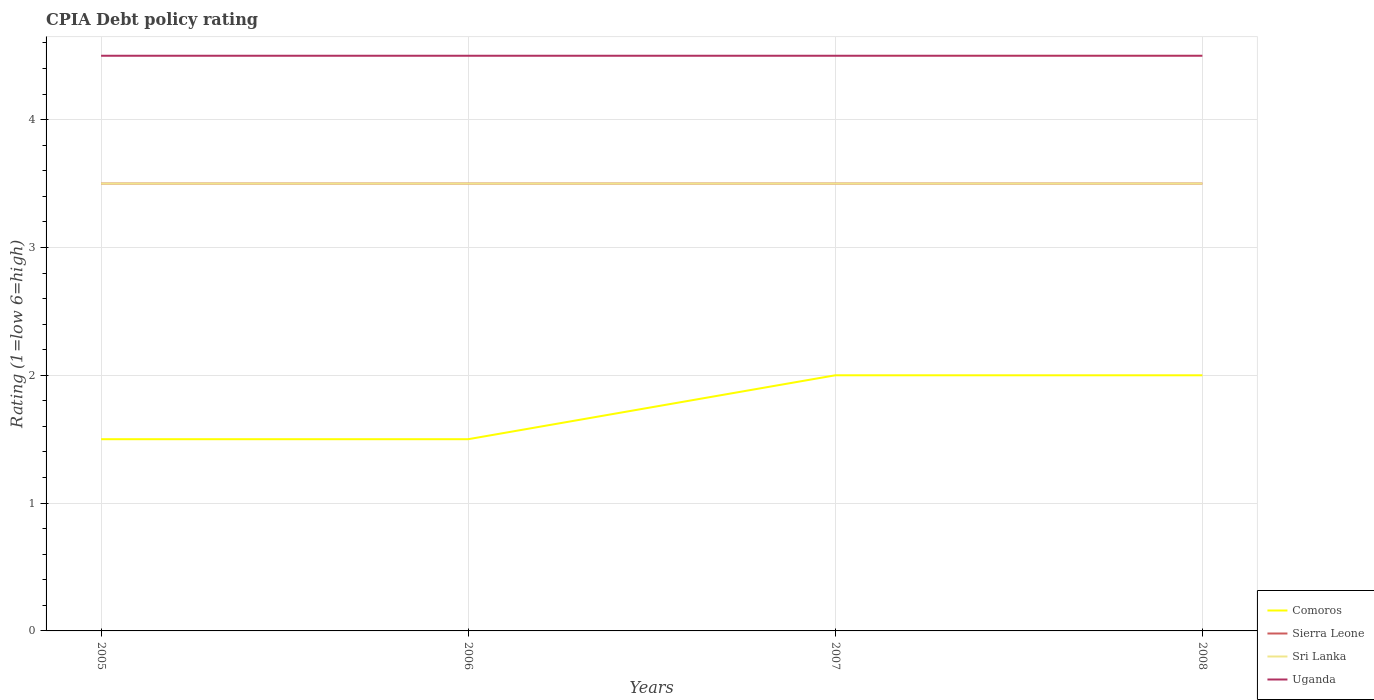Across all years, what is the maximum CPIA rating in Uganda?
Offer a terse response. 4.5. What is the difference between the highest and the second highest CPIA rating in Sri Lanka?
Ensure brevity in your answer.  0. Is the CPIA rating in Sri Lanka strictly greater than the CPIA rating in Sierra Leone over the years?
Your answer should be compact. No. How many years are there in the graph?
Your answer should be very brief. 4. What is the difference between two consecutive major ticks on the Y-axis?
Offer a terse response. 1. Are the values on the major ticks of Y-axis written in scientific E-notation?
Make the answer very short. No. Does the graph contain any zero values?
Give a very brief answer. No. Does the graph contain grids?
Offer a terse response. Yes. Where does the legend appear in the graph?
Make the answer very short. Bottom right. How many legend labels are there?
Your response must be concise. 4. How are the legend labels stacked?
Make the answer very short. Vertical. What is the title of the graph?
Provide a succinct answer. CPIA Debt policy rating. What is the label or title of the X-axis?
Offer a terse response. Years. What is the Rating (1=low 6=high) in Comoros in 2005?
Your answer should be very brief. 1.5. What is the Rating (1=low 6=high) of Comoros in 2006?
Offer a terse response. 1.5. What is the Rating (1=low 6=high) of Sierra Leone in 2006?
Your answer should be compact. 3.5. What is the Rating (1=low 6=high) in Comoros in 2007?
Give a very brief answer. 2. What is the Rating (1=low 6=high) in Sri Lanka in 2007?
Ensure brevity in your answer.  3.5. What is the Rating (1=low 6=high) of Uganda in 2007?
Make the answer very short. 4.5. What is the Rating (1=low 6=high) of Sierra Leone in 2008?
Make the answer very short. 3.5. What is the Rating (1=low 6=high) of Uganda in 2008?
Make the answer very short. 4.5. Across all years, what is the maximum Rating (1=low 6=high) of Sierra Leone?
Offer a terse response. 3.5. Across all years, what is the maximum Rating (1=low 6=high) of Uganda?
Your response must be concise. 4.5. Across all years, what is the minimum Rating (1=low 6=high) of Sierra Leone?
Offer a terse response. 3.5. Across all years, what is the minimum Rating (1=low 6=high) of Sri Lanka?
Provide a succinct answer. 3.5. Across all years, what is the minimum Rating (1=low 6=high) of Uganda?
Offer a very short reply. 4.5. What is the total Rating (1=low 6=high) of Comoros in the graph?
Offer a terse response. 7. What is the difference between the Rating (1=low 6=high) of Comoros in 2005 and that in 2006?
Provide a succinct answer. 0. What is the difference between the Rating (1=low 6=high) in Sierra Leone in 2005 and that in 2006?
Your response must be concise. 0. What is the difference between the Rating (1=low 6=high) of Uganda in 2005 and that in 2006?
Offer a terse response. 0. What is the difference between the Rating (1=low 6=high) in Sri Lanka in 2005 and that in 2007?
Provide a succinct answer. 0. What is the difference between the Rating (1=low 6=high) of Uganda in 2005 and that in 2007?
Ensure brevity in your answer.  0. What is the difference between the Rating (1=low 6=high) in Sri Lanka in 2005 and that in 2008?
Give a very brief answer. 0. What is the difference between the Rating (1=low 6=high) in Uganda in 2005 and that in 2008?
Provide a succinct answer. 0. What is the difference between the Rating (1=low 6=high) in Uganda in 2006 and that in 2007?
Offer a terse response. 0. What is the difference between the Rating (1=low 6=high) of Comoros in 2006 and that in 2008?
Give a very brief answer. -0.5. What is the difference between the Rating (1=low 6=high) in Sierra Leone in 2006 and that in 2008?
Give a very brief answer. 0. What is the difference between the Rating (1=low 6=high) of Sri Lanka in 2006 and that in 2008?
Ensure brevity in your answer.  0. What is the difference between the Rating (1=low 6=high) in Uganda in 2006 and that in 2008?
Your response must be concise. 0. What is the difference between the Rating (1=low 6=high) in Comoros in 2007 and that in 2008?
Your response must be concise. 0. What is the difference between the Rating (1=low 6=high) in Sri Lanka in 2007 and that in 2008?
Make the answer very short. 0. What is the difference between the Rating (1=low 6=high) in Uganda in 2007 and that in 2008?
Offer a terse response. 0. What is the difference between the Rating (1=low 6=high) of Sierra Leone in 2005 and the Rating (1=low 6=high) of Sri Lanka in 2006?
Your response must be concise. 0. What is the difference between the Rating (1=low 6=high) in Sierra Leone in 2005 and the Rating (1=low 6=high) in Uganda in 2006?
Ensure brevity in your answer.  -1. What is the difference between the Rating (1=low 6=high) in Sri Lanka in 2005 and the Rating (1=low 6=high) in Uganda in 2006?
Give a very brief answer. -1. What is the difference between the Rating (1=low 6=high) of Sierra Leone in 2005 and the Rating (1=low 6=high) of Sri Lanka in 2007?
Offer a terse response. 0. What is the difference between the Rating (1=low 6=high) of Sri Lanka in 2005 and the Rating (1=low 6=high) of Uganda in 2007?
Your answer should be very brief. -1. What is the difference between the Rating (1=low 6=high) of Comoros in 2005 and the Rating (1=low 6=high) of Sierra Leone in 2008?
Give a very brief answer. -2. What is the difference between the Rating (1=low 6=high) of Comoros in 2006 and the Rating (1=low 6=high) of Sierra Leone in 2007?
Your answer should be compact. -2. What is the difference between the Rating (1=low 6=high) of Sierra Leone in 2006 and the Rating (1=low 6=high) of Uganda in 2007?
Make the answer very short. -1. What is the difference between the Rating (1=low 6=high) of Comoros in 2006 and the Rating (1=low 6=high) of Sri Lanka in 2008?
Keep it short and to the point. -2. What is the difference between the Rating (1=low 6=high) in Sierra Leone in 2006 and the Rating (1=low 6=high) in Sri Lanka in 2008?
Make the answer very short. 0. What is the difference between the Rating (1=low 6=high) in Comoros in 2007 and the Rating (1=low 6=high) in Sierra Leone in 2008?
Give a very brief answer. -1.5. What is the difference between the Rating (1=low 6=high) in Comoros in 2007 and the Rating (1=low 6=high) in Sri Lanka in 2008?
Your answer should be very brief. -1.5. What is the difference between the Rating (1=low 6=high) in Sierra Leone in 2007 and the Rating (1=low 6=high) in Uganda in 2008?
Offer a terse response. -1. What is the difference between the Rating (1=low 6=high) of Sri Lanka in 2007 and the Rating (1=low 6=high) of Uganda in 2008?
Provide a succinct answer. -1. What is the average Rating (1=low 6=high) in Comoros per year?
Provide a succinct answer. 1.75. What is the average Rating (1=low 6=high) in Sri Lanka per year?
Your response must be concise. 3.5. In the year 2005, what is the difference between the Rating (1=low 6=high) of Comoros and Rating (1=low 6=high) of Sierra Leone?
Provide a succinct answer. -2. In the year 2005, what is the difference between the Rating (1=low 6=high) in Comoros and Rating (1=low 6=high) in Sri Lanka?
Your answer should be compact. -2. In the year 2005, what is the difference between the Rating (1=low 6=high) of Sierra Leone and Rating (1=low 6=high) of Sri Lanka?
Keep it short and to the point. 0. In the year 2005, what is the difference between the Rating (1=low 6=high) in Sierra Leone and Rating (1=low 6=high) in Uganda?
Your answer should be compact. -1. In the year 2006, what is the difference between the Rating (1=low 6=high) of Comoros and Rating (1=low 6=high) of Sierra Leone?
Offer a very short reply. -2. In the year 2006, what is the difference between the Rating (1=low 6=high) in Comoros and Rating (1=low 6=high) in Sri Lanka?
Keep it short and to the point. -2. In the year 2006, what is the difference between the Rating (1=low 6=high) in Comoros and Rating (1=low 6=high) in Uganda?
Give a very brief answer. -3. In the year 2006, what is the difference between the Rating (1=low 6=high) in Sierra Leone and Rating (1=low 6=high) in Sri Lanka?
Provide a succinct answer. 0. In the year 2007, what is the difference between the Rating (1=low 6=high) in Comoros and Rating (1=low 6=high) in Uganda?
Keep it short and to the point. -2.5. In the year 2007, what is the difference between the Rating (1=low 6=high) of Sierra Leone and Rating (1=low 6=high) of Sri Lanka?
Make the answer very short. 0. In the year 2007, what is the difference between the Rating (1=low 6=high) of Sri Lanka and Rating (1=low 6=high) of Uganda?
Your response must be concise. -1. In the year 2008, what is the difference between the Rating (1=low 6=high) in Comoros and Rating (1=low 6=high) in Sri Lanka?
Offer a terse response. -1.5. In the year 2008, what is the difference between the Rating (1=low 6=high) of Comoros and Rating (1=low 6=high) of Uganda?
Make the answer very short. -2.5. In the year 2008, what is the difference between the Rating (1=low 6=high) of Sierra Leone and Rating (1=low 6=high) of Sri Lanka?
Make the answer very short. 0. In the year 2008, what is the difference between the Rating (1=low 6=high) in Sri Lanka and Rating (1=low 6=high) in Uganda?
Offer a very short reply. -1. What is the ratio of the Rating (1=low 6=high) of Comoros in 2005 to that in 2006?
Your response must be concise. 1. What is the ratio of the Rating (1=low 6=high) in Sierra Leone in 2005 to that in 2006?
Ensure brevity in your answer.  1. What is the ratio of the Rating (1=low 6=high) in Sri Lanka in 2005 to that in 2006?
Make the answer very short. 1. What is the ratio of the Rating (1=low 6=high) of Uganda in 2005 to that in 2006?
Your answer should be very brief. 1. What is the ratio of the Rating (1=low 6=high) of Uganda in 2005 to that in 2007?
Give a very brief answer. 1. What is the ratio of the Rating (1=low 6=high) in Comoros in 2005 to that in 2008?
Your response must be concise. 0.75. What is the ratio of the Rating (1=low 6=high) of Sierra Leone in 2005 to that in 2008?
Keep it short and to the point. 1. What is the ratio of the Rating (1=low 6=high) in Comoros in 2006 to that in 2007?
Provide a succinct answer. 0.75. What is the ratio of the Rating (1=low 6=high) of Sierra Leone in 2006 to that in 2007?
Your response must be concise. 1. What is the ratio of the Rating (1=low 6=high) of Uganda in 2006 to that in 2007?
Your answer should be very brief. 1. What is the ratio of the Rating (1=low 6=high) of Sierra Leone in 2006 to that in 2008?
Keep it short and to the point. 1. What is the ratio of the Rating (1=low 6=high) in Sri Lanka in 2006 to that in 2008?
Keep it short and to the point. 1. What is the ratio of the Rating (1=low 6=high) in Comoros in 2007 to that in 2008?
Provide a short and direct response. 1. What is the ratio of the Rating (1=low 6=high) of Sierra Leone in 2007 to that in 2008?
Your response must be concise. 1. What is the ratio of the Rating (1=low 6=high) of Sri Lanka in 2007 to that in 2008?
Give a very brief answer. 1. What is the difference between the highest and the second highest Rating (1=low 6=high) in Sri Lanka?
Your answer should be compact. 0. What is the difference between the highest and the second highest Rating (1=low 6=high) in Uganda?
Your answer should be very brief. 0. What is the difference between the highest and the lowest Rating (1=low 6=high) in Sri Lanka?
Provide a short and direct response. 0. What is the difference between the highest and the lowest Rating (1=low 6=high) in Uganda?
Keep it short and to the point. 0. 